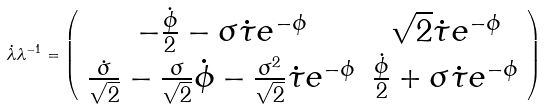<formula> <loc_0><loc_0><loc_500><loc_500>\dot { \lambda } \lambda ^ { - 1 } = \left ( \begin{array} { c c } { - \frac { \dot { \phi } } { 2 } - \sigma \dot { \tau } e ^ { - \phi } } & { \sqrt { 2 } \dot { \tau } e ^ { - \phi } } \\ { \frac { \dot { \sigma } } { \sqrt { 2 } } - \frac { \sigma } { \sqrt { 2 } } \dot { \phi } - \frac { \sigma ^ { 2 } } { \sqrt { 2 } } \dot { \tau } e ^ { - \phi } } & { \frac { \dot { \phi } } { 2 } + \sigma \dot { \tau } e ^ { - \phi } } \end{array} \right )</formula> 